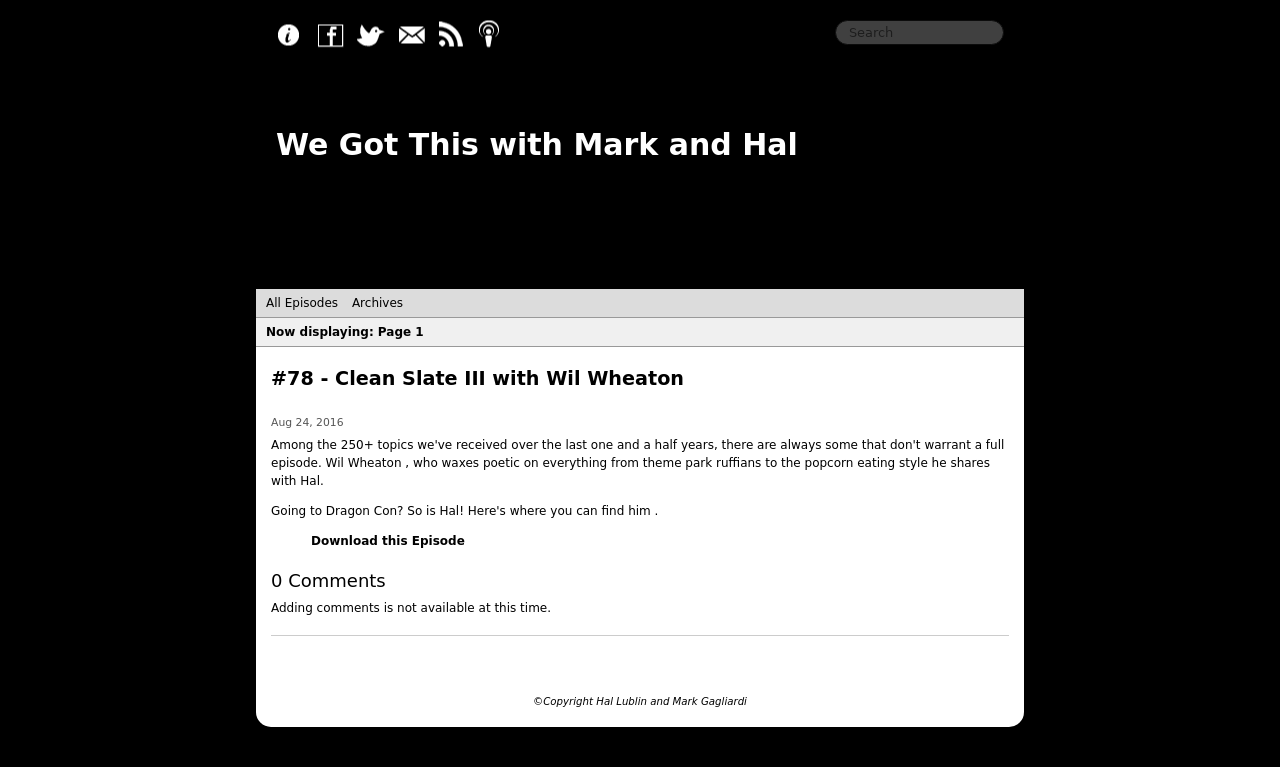What are some key functionalities that this type of website must have? For a podcast website as seen in the image, key functionalities would include a media player integrated into each podcast episode listing, allowing users to easily listen to or download episodes. Navigation links for sorting by episode number, date, or tag are crucial for user engagement. Incorporating social share buttons helps in promoting the content across different social media platforms. A search bar would enhance the user experience by letting visitors quickly find specific episodes or topics of interest. Is there a way to improve interaction with the audience using this website? Indeed, integrating a comment section below each podcast episode could be a significant improvement for interaction. Enabling users to leave feedback or discuss the episode content promotes community engagement. Additionally, featuring a mailing list sign-up form can keep the audience updated on new episodes and special events. Providing a contact form or linking to a forum can further associations with the listener community. 